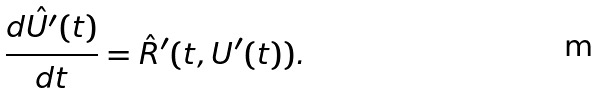<formula> <loc_0><loc_0><loc_500><loc_500>\frac { d \hat { U ^ { \prime } } ( t ) } { d t } = \hat { R } ^ { \prime } ( t , U ^ { \prime } ( t ) ) .</formula> 